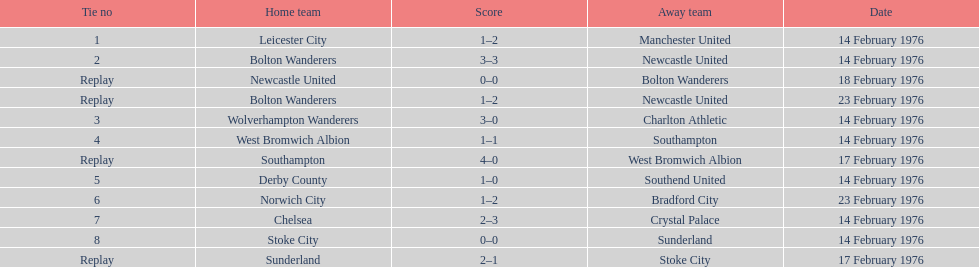Alongside leicester city and manchester united, which teams played on the same day? Bolton Wanderers, Newcastle United. 